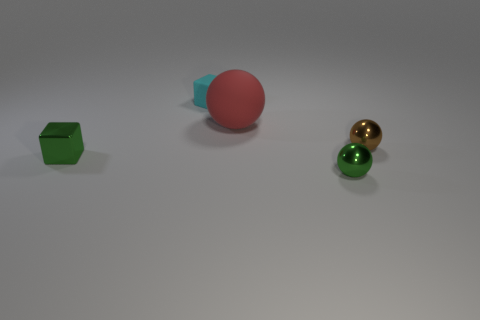There is a big sphere; is its color the same as the metal ball that is behind the green metal cube?
Give a very brief answer. No. Are there any small metal things that are on the right side of the matte object that is left of the ball that is behind the brown shiny object?
Your answer should be compact. Yes. The tiny cyan object that is made of the same material as the large thing is what shape?
Provide a short and direct response. Cube. There is a cyan rubber object; what shape is it?
Your answer should be very brief. Cube. There is a small thing behind the brown object; does it have the same shape as the large red object?
Ensure brevity in your answer.  No. Is the number of large red objects that are behind the green cube greater than the number of small metal cubes that are behind the cyan matte block?
Keep it short and to the point. Yes. What number of other objects are the same size as the red matte thing?
Ensure brevity in your answer.  0. There is a red thing; does it have the same shape as the green metallic thing that is right of the tiny green shiny block?
Provide a short and direct response. Yes. What number of metal things are either large objects or green objects?
Give a very brief answer. 2. Is there a object of the same color as the metallic cube?
Provide a short and direct response. Yes. 